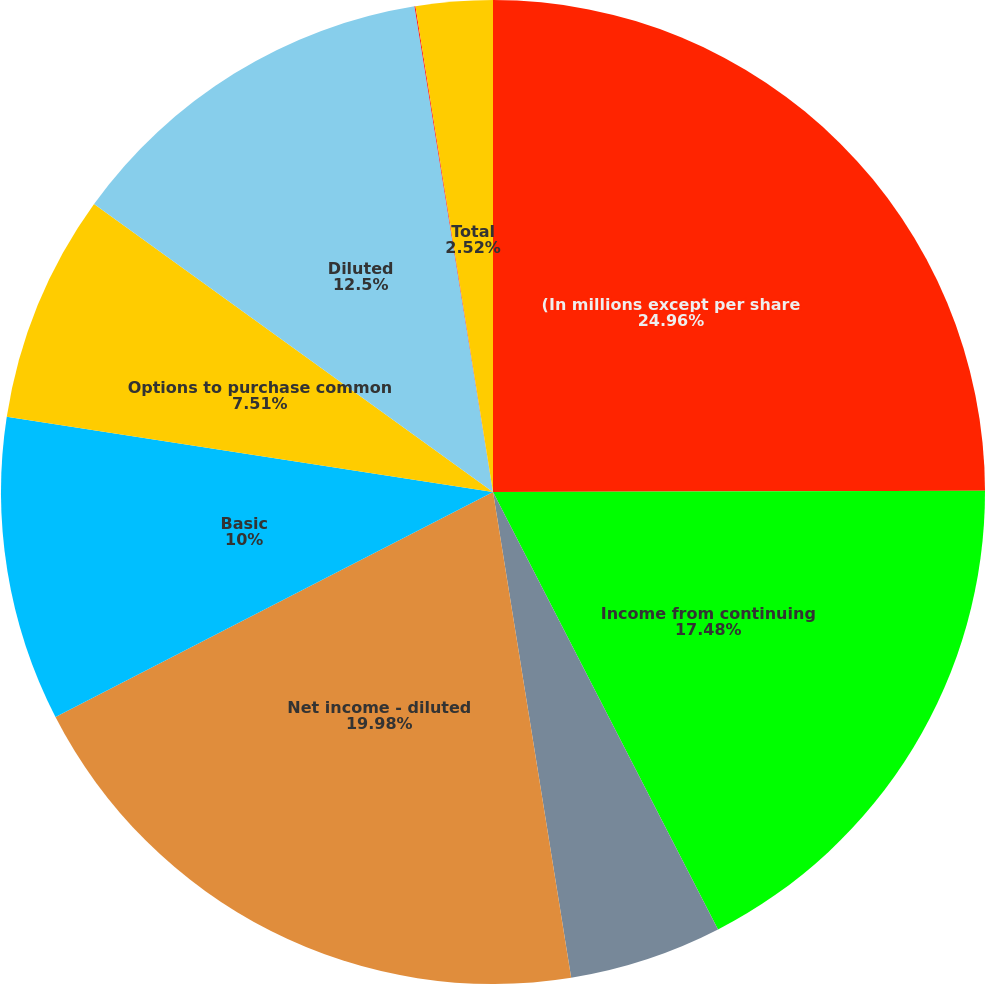Convert chart to OTSL. <chart><loc_0><loc_0><loc_500><loc_500><pie_chart><fcel>(In millions except per share<fcel>Income from continuing<fcel>Discontinued operations<fcel>Net income - diluted<fcel>Basic<fcel>Options to purchase common<fcel>Diluted<fcel>Continuing operations<fcel>Total<nl><fcel>24.96%<fcel>17.48%<fcel>5.02%<fcel>19.98%<fcel>10.0%<fcel>7.51%<fcel>12.5%<fcel>0.03%<fcel>2.52%<nl></chart> 